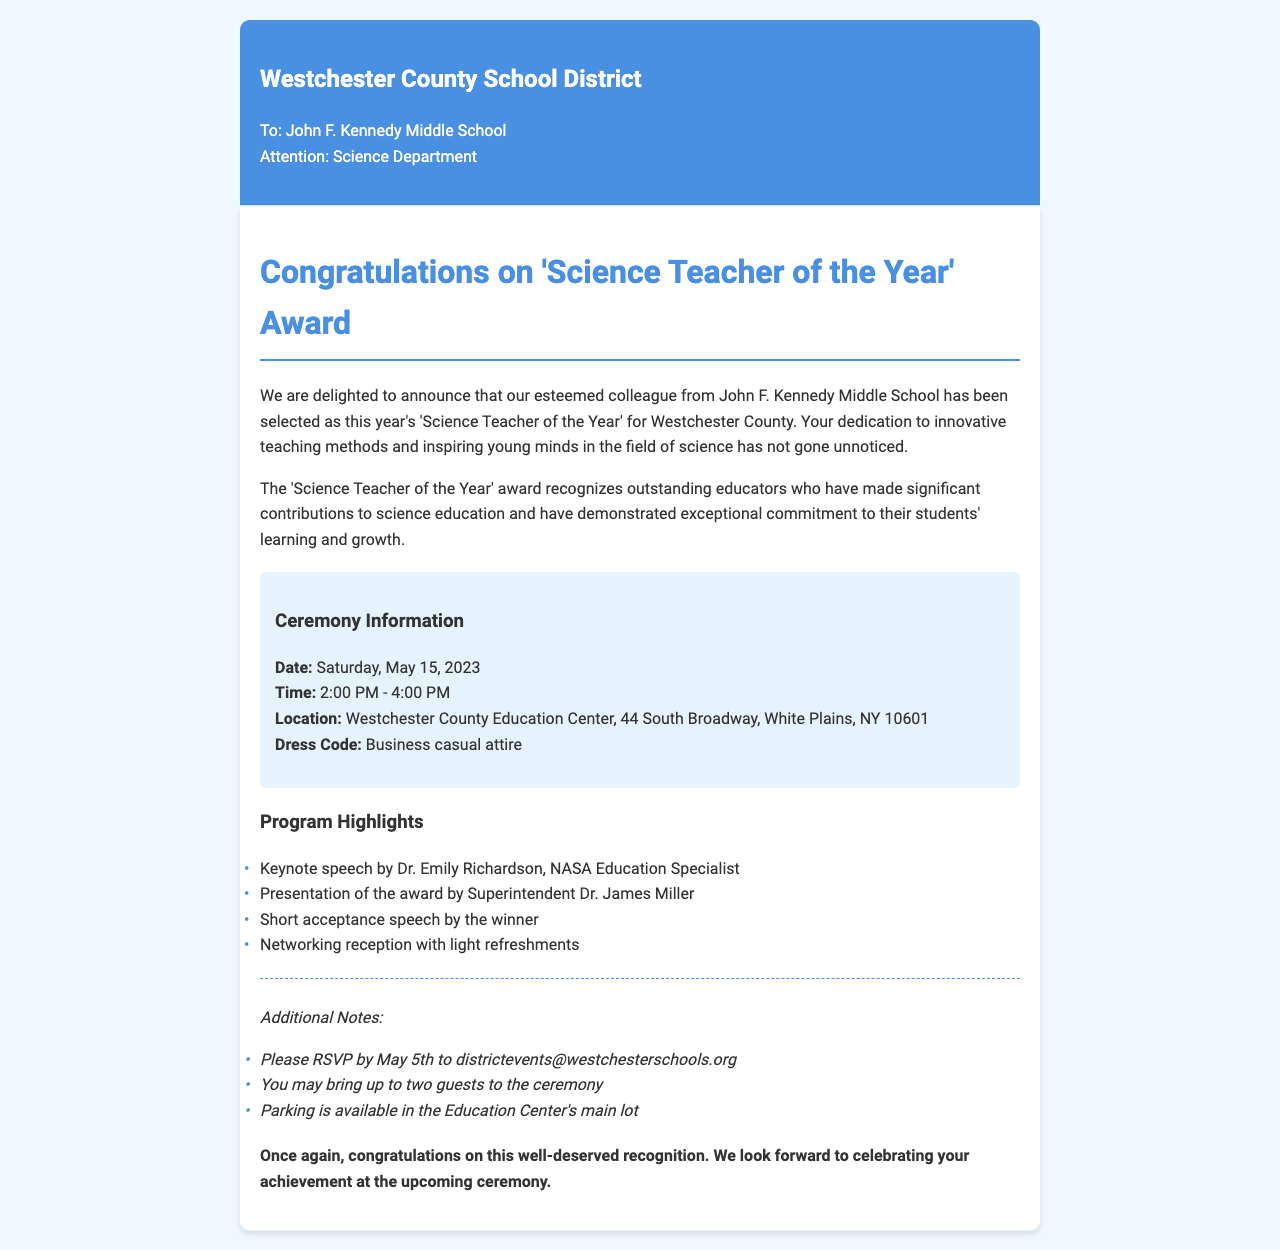what award has been won? The document announces the 'Science Teacher of the Year' award given to a colleague from John F. Kennedy Middle School.
Answer: 'Science Teacher of the Year' who presents the award? The document states that the award will be presented by Superintendent Dr. James Miller.
Answer: Dr. James Miller when is the ceremony date? The ceremony date is explicitly mentioned in the document, which is Saturday, May 15, 2023.
Answer: Saturday, May 15, 2023 what is the dress code for the ceremony? The dress code for the awards ceremony is mentioned in the document.
Answer: Business casual attire how many guests can the winner bring? The document states that the winner may bring up to two guests to the ceremony.
Answer: two guests what time does the ceremony start? The document includes specific starting time for the ceremony, which is 2:00 PM.
Answer: 2:00 PM who is the keynote speaker? The keynote speaker for the ceremony is named in the document as Dr. Emily Richardson, NASA Education Specialist.
Answer: Dr. Emily Richardson what is required to attend the ceremony? The document requires an RSVP to attend the ceremony, due by May 5th.
Answer: RSVP by May 5th 